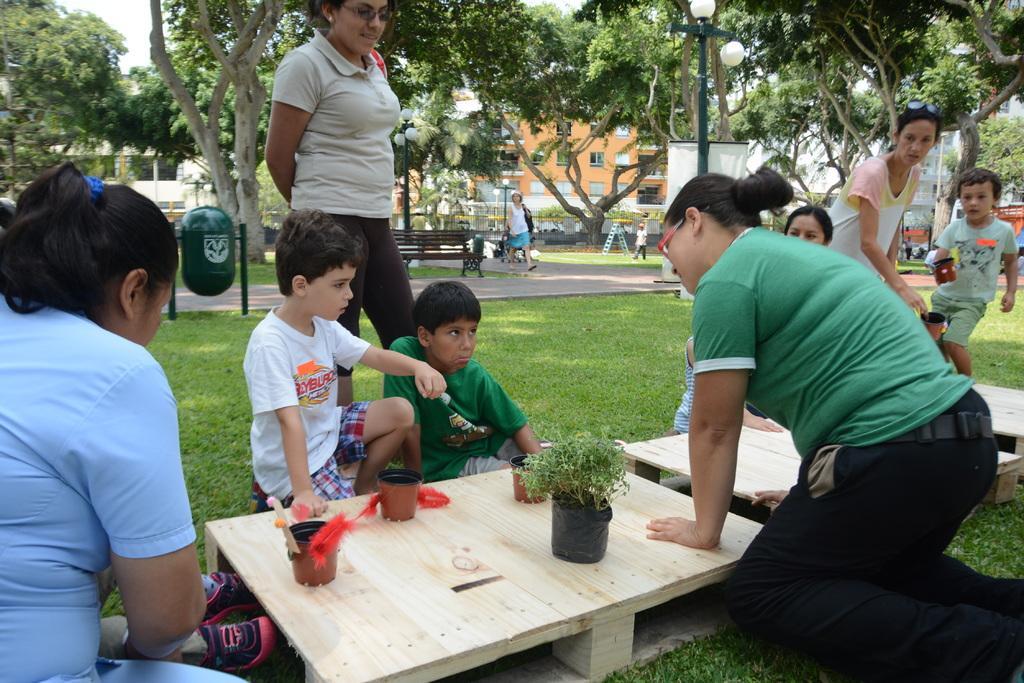How would you summarize this image in a sentence or two? In this image we can see a group of persons are sitting, and her two persons are standing, and here is the table and flower pots on it, and here is the grass, and here are the trees, and here is the woman walking on the road, and here is the bench. 